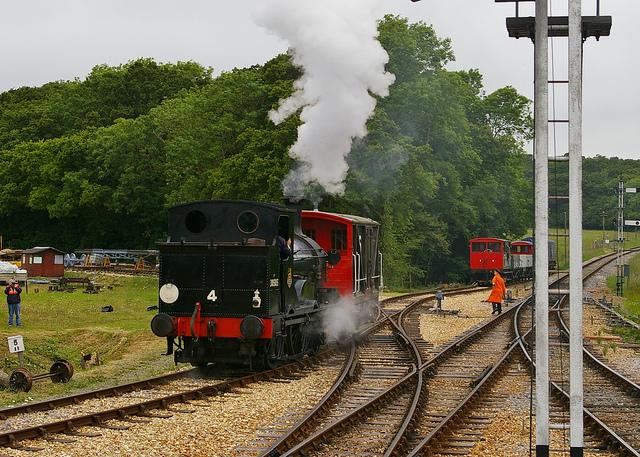Why is the man wearing an orange jacket? Please explain your reasoning. visibility. He needs to maintain visibility for safety reasons. 